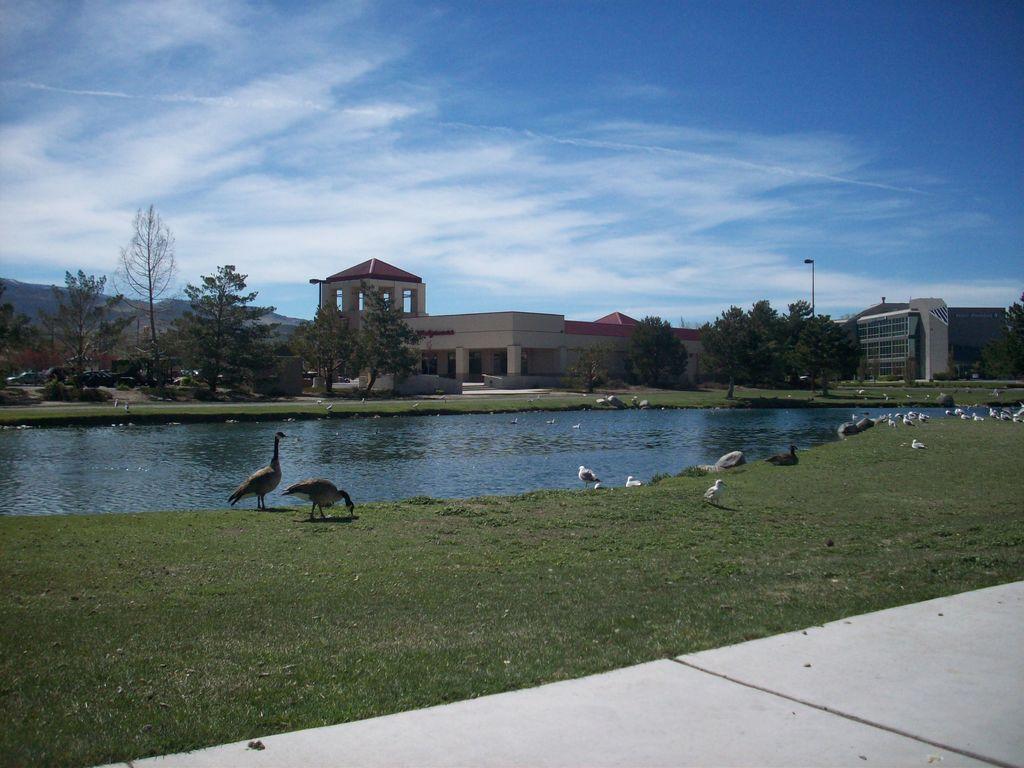In one or two sentences, can you explain what this image depicts? In the center of the image we can see buildings, trees, electric light pole, grass, hills are present. At the bottom of the image we can see ground, grass are there. In the middle of the image we can see water and some birds are there. At the top of the image clouds are present in the sky. 